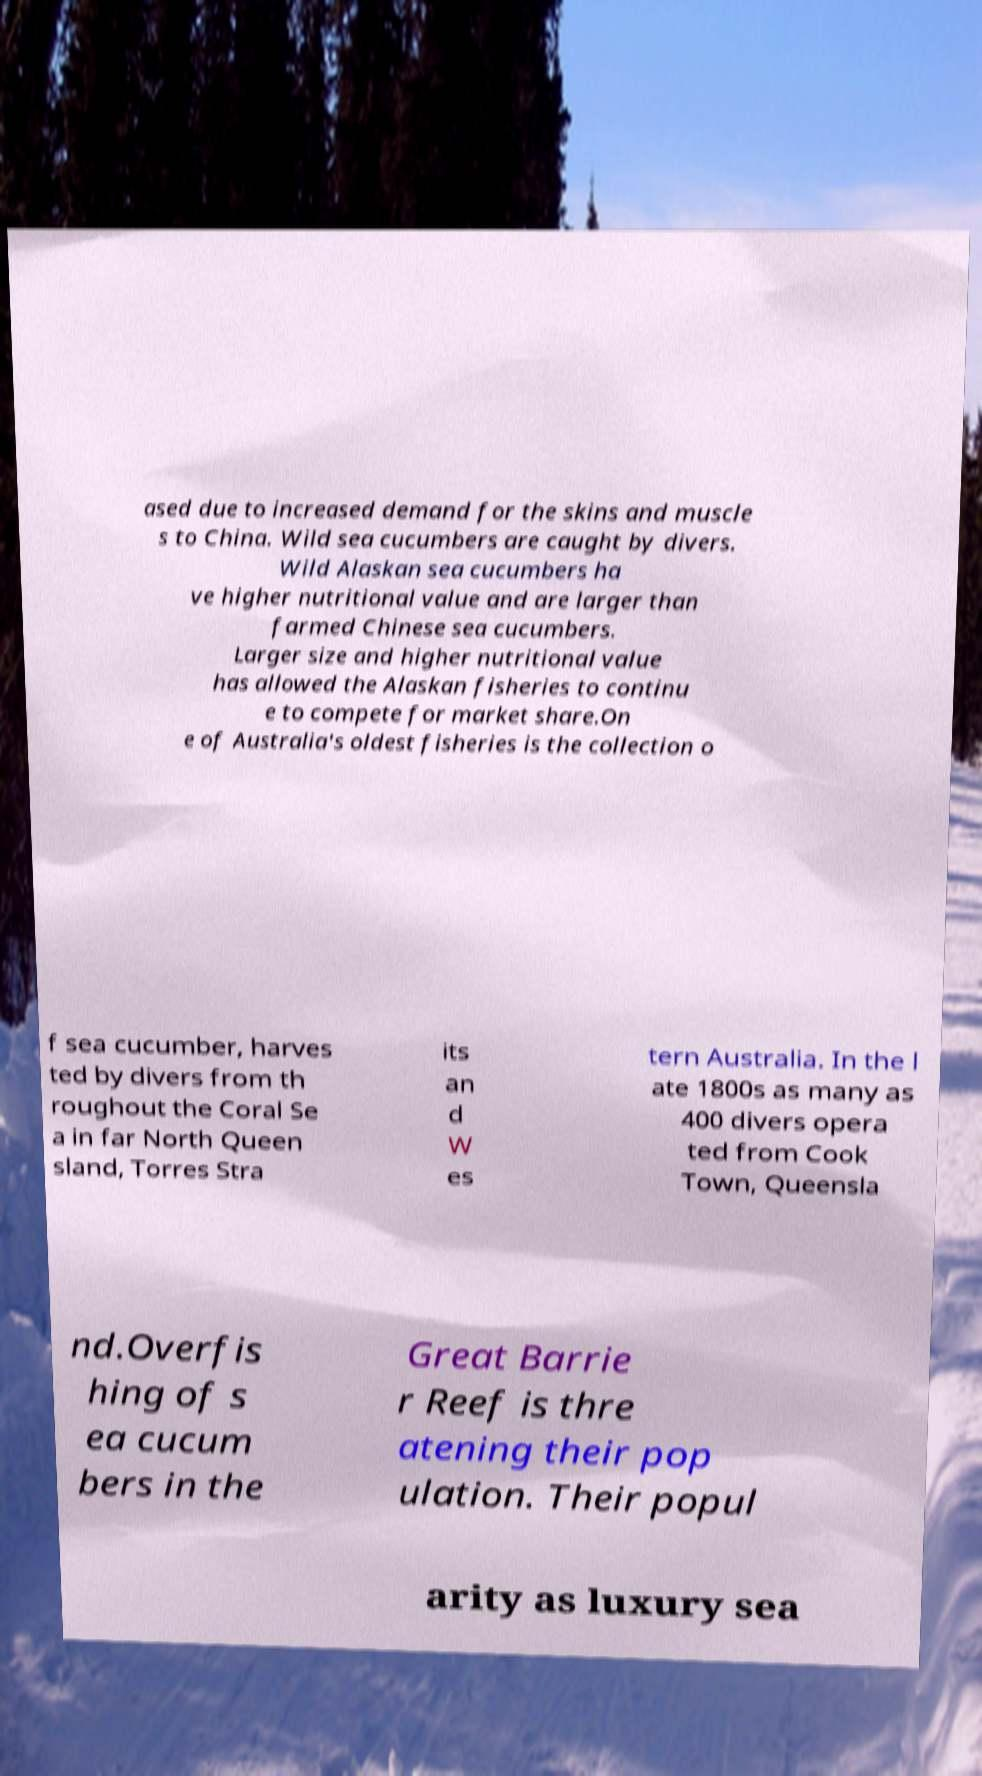I need the written content from this picture converted into text. Can you do that? ased due to increased demand for the skins and muscle s to China. Wild sea cucumbers are caught by divers. Wild Alaskan sea cucumbers ha ve higher nutritional value and are larger than farmed Chinese sea cucumbers. Larger size and higher nutritional value has allowed the Alaskan fisheries to continu e to compete for market share.On e of Australia's oldest fisheries is the collection o f sea cucumber, harves ted by divers from th roughout the Coral Se a in far North Queen sland, Torres Stra its an d W es tern Australia. In the l ate 1800s as many as 400 divers opera ted from Cook Town, Queensla nd.Overfis hing of s ea cucum bers in the Great Barrie r Reef is thre atening their pop ulation. Their popul arity as luxury sea 